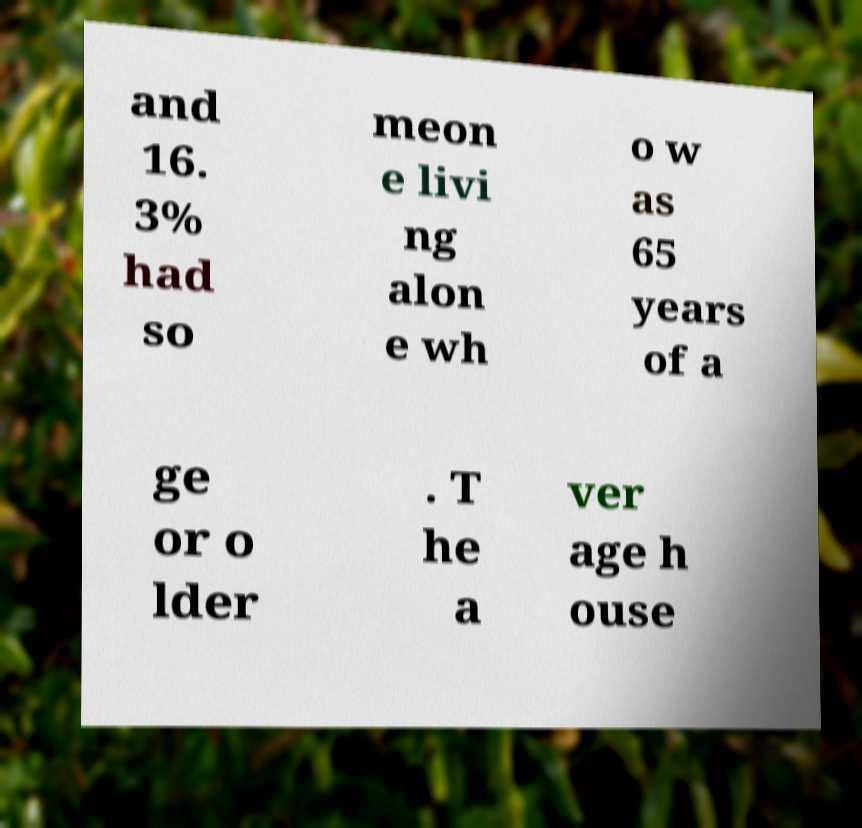There's text embedded in this image that I need extracted. Can you transcribe it verbatim? and 16. 3% had so meon e livi ng alon e wh o w as 65 years of a ge or o lder . T he a ver age h ouse 